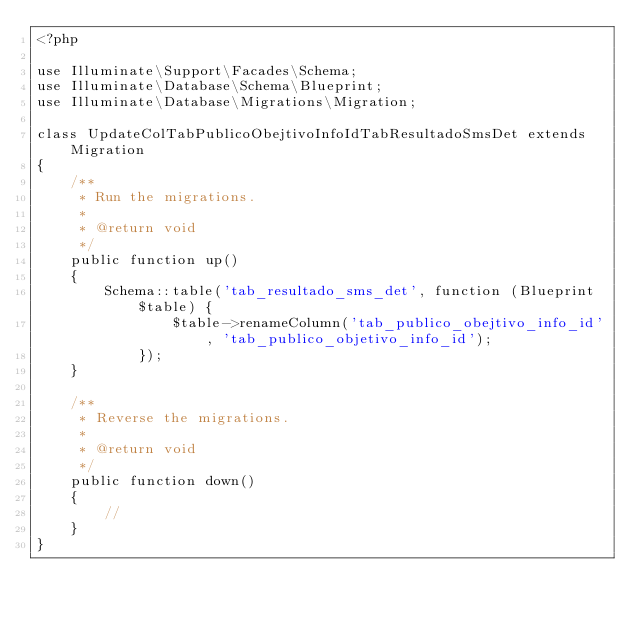Convert code to text. <code><loc_0><loc_0><loc_500><loc_500><_PHP_><?php

use Illuminate\Support\Facades\Schema;
use Illuminate\Database\Schema\Blueprint;
use Illuminate\Database\Migrations\Migration;

class UpdateColTabPublicoObejtivoInfoIdTabResultadoSmsDet extends Migration
{
    /**
     * Run the migrations.
     *
     * @return void
     */
    public function up()
    {
        Schema::table('tab_resultado_sms_det', function (Blueprint $table) {
                $table->renameColumn('tab_publico_obejtivo_info_id', 'tab_publico_objetivo_info_id');
            });
    }

    /**
     * Reverse the migrations.
     *
     * @return void
     */
    public function down()
    {
        //
    }
}
</code> 